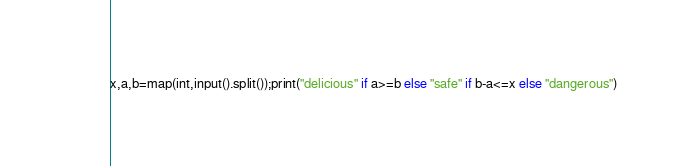<code> <loc_0><loc_0><loc_500><loc_500><_Python_>x,a,b=map(int,input().split());print("delicious" if a>=b else "safe" if b-a<=x else "dangerous")</code> 